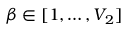Convert formula to latex. <formula><loc_0><loc_0><loc_500><loc_500>\beta \in [ 1 , \dots , V _ { 2 } ]</formula> 